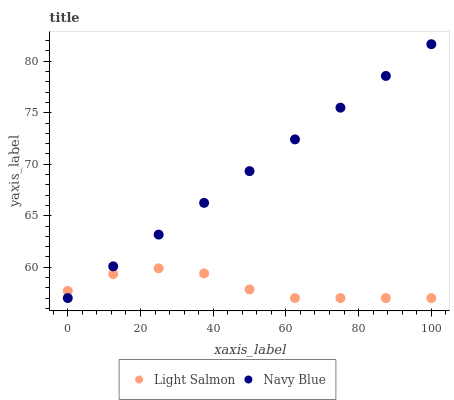Does Light Salmon have the minimum area under the curve?
Answer yes or no. Yes. Does Navy Blue have the maximum area under the curve?
Answer yes or no. Yes. Does Light Salmon have the maximum area under the curve?
Answer yes or no. No. Is Navy Blue the smoothest?
Answer yes or no. Yes. Is Light Salmon the roughest?
Answer yes or no. Yes. Is Light Salmon the smoothest?
Answer yes or no. No. Does Navy Blue have the lowest value?
Answer yes or no. Yes. Does Navy Blue have the highest value?
Answer yes or no. Yes. Does Light Salmon have the highest value?
Answer yes or no. No. Does Light Salmon intersect Navy Blue?
Answer yes or no. Yes. Is Light Salmon less than Navy Blue?
Answer yes or no. No. Is Light Salmon greater than Navy Blue?
Answer yes or no. No. 